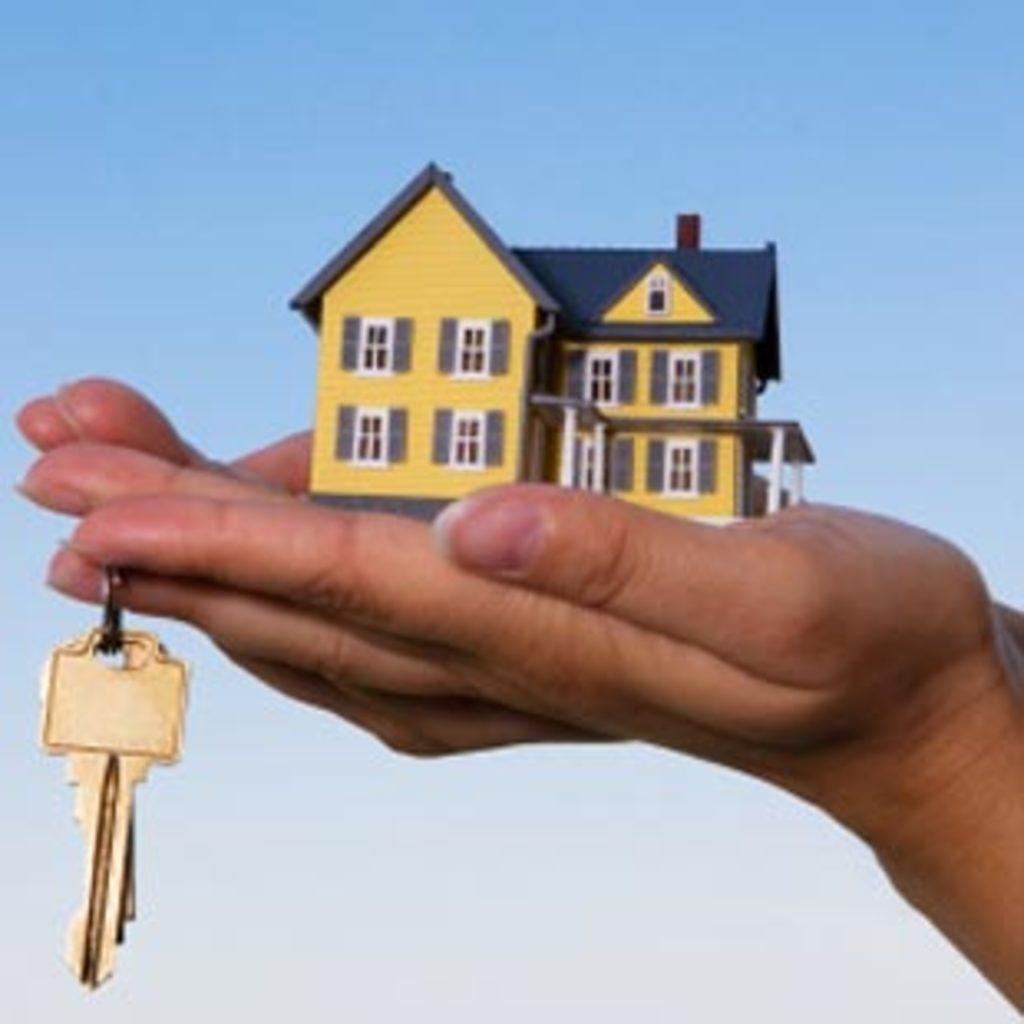In one or two sentences, can you explain what this image depicts? In the image there is a hand and in the palm of the hand, there is a house toy and one of the fingers is holding the keys. 